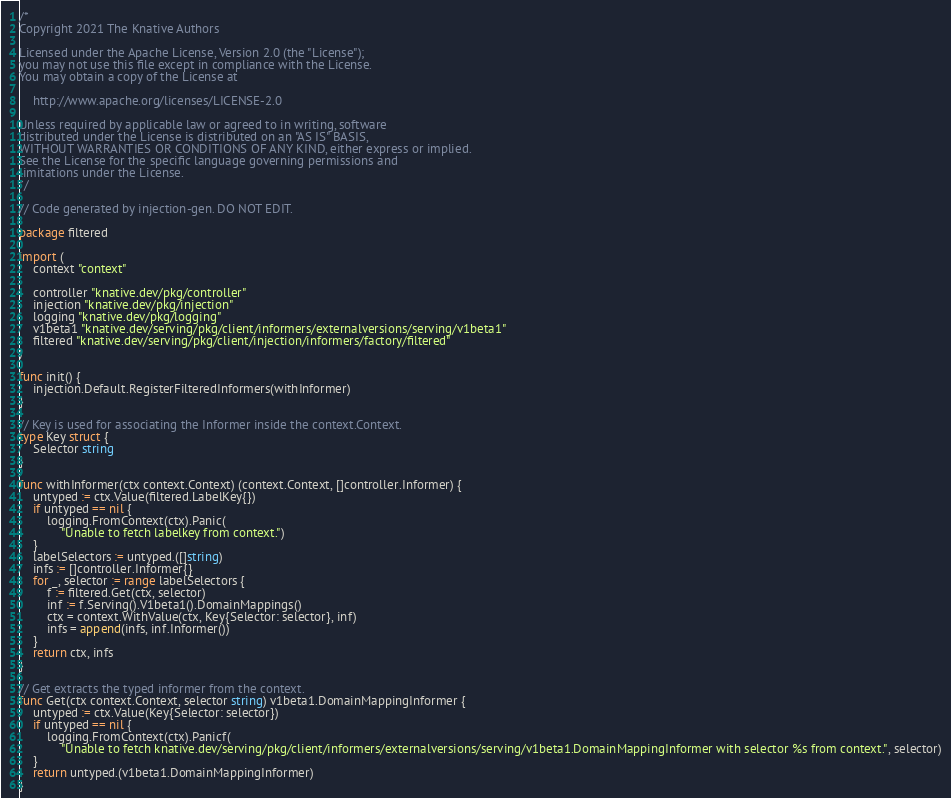<code> <loc_0><loc_0><loc_500><loc_500><_Go_>/*
Copyright 2021 The Knative Authors

Licensed under the Apache License, Version 2.0 (the "License");
you may not use this file except in compliance with the License.
You may obtain a copy of the License at

    http://www.apache.org/licenses/LICENSE-2.0

Unless required by applicable law or agreed to in writing, software
distributed under the License is distributed on an "AS IS" BASIS,
WITHOUT WARRANTIES OR CONDITIONS OF ANY KIND, either express or implied.
See the License for the specific language governing permissions and
limitations under the License.
*/

// Code generated by injection-gen. DO NOT EDIT.

package filtered

import (
	context "context"

	controller "knative.dev/pkg/controller"
	injection "knative.dev/pkg/injection"
	logging "knative.dev/pkg/logging"
	v1beta1 "knative.dev/serving/pkg/client/informers/externalversions/serving/v1beta1"
	filtered "knative.dev/serving/pkg/client/injection/informers/factory/filtered"
)

func init() {
	injection.Default.RegisterFilteredInformers(withInformer)
}

// Key is used for associating the Informer inside the context.Context.
type Key struct {
	Selector string
}

func withInformer(ctx context.Context) (context.Context, []controller.Informer) {
	untyped := ctx.Value(filtered.LabelKey{})
	if untyped == nil {
		logging.FromContext(ctx).Panic(
			"Unable to fetch labelkey from context.")
	}
	labelSelectors := untyped.([]string)
	infs := []controller.Informer{}
	for _, selector := range labelSelectors {
		f := filtered.Get(ctx, selector)
		inf := f.Serving().V1beta1().DomainMappings()
		ctx = context.WithValue(ctx, Key{Selector: selector}, inf)
		infs = append(infs, inf.Informer())
	}
	return ctx, infs
}

// Get extracts the typed informer from the context.
func Get(ctx context.Context, selector string) v1beta1.DomainMappingInformer {
	untyped := ctx.Value(Key{Selector: selector})
	if untyped == nil {
		logging.FromContext(ctx).Panicf(
			"Unable to fetch knative.dev/serving/pkg/client/informers/externalversions/serving/v1beta1.DomainMappingInformer with selector %s from context.", selector)
	}
	return untyped.(v1beta1.DomainMappingInformer)
}
</code> 